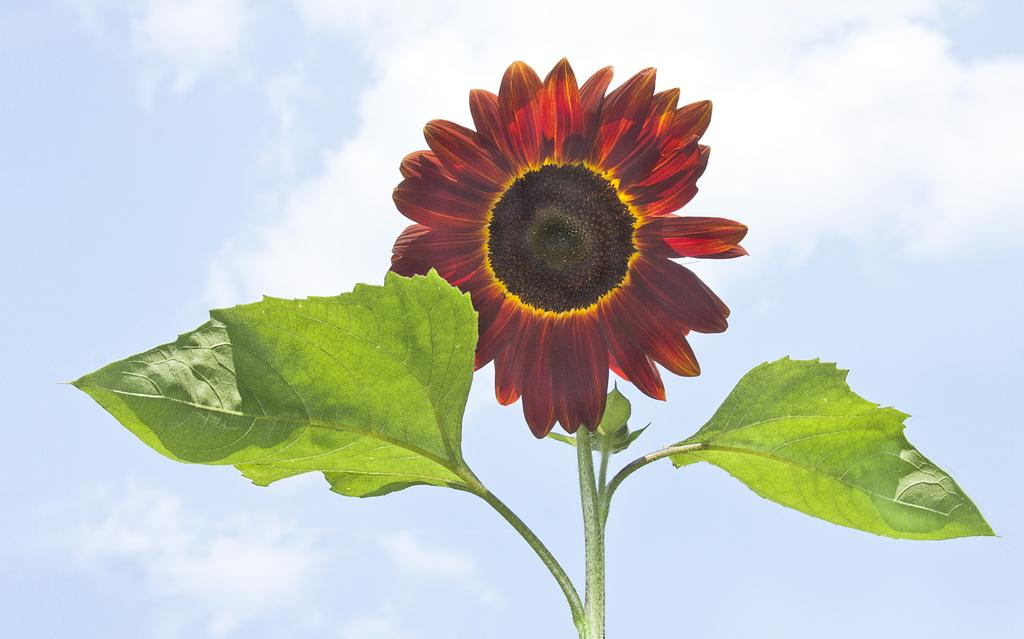What type of plant is visible in the image? There is a flower in the image. What else can be seen on the plant in the image? There are leaves in the image. What is visible in the sky in the image? There are clouds visible in the sky. What type of needle is being used by the bear in the image? There is no bear or needle present in the image; it only features a flower and leaves. 